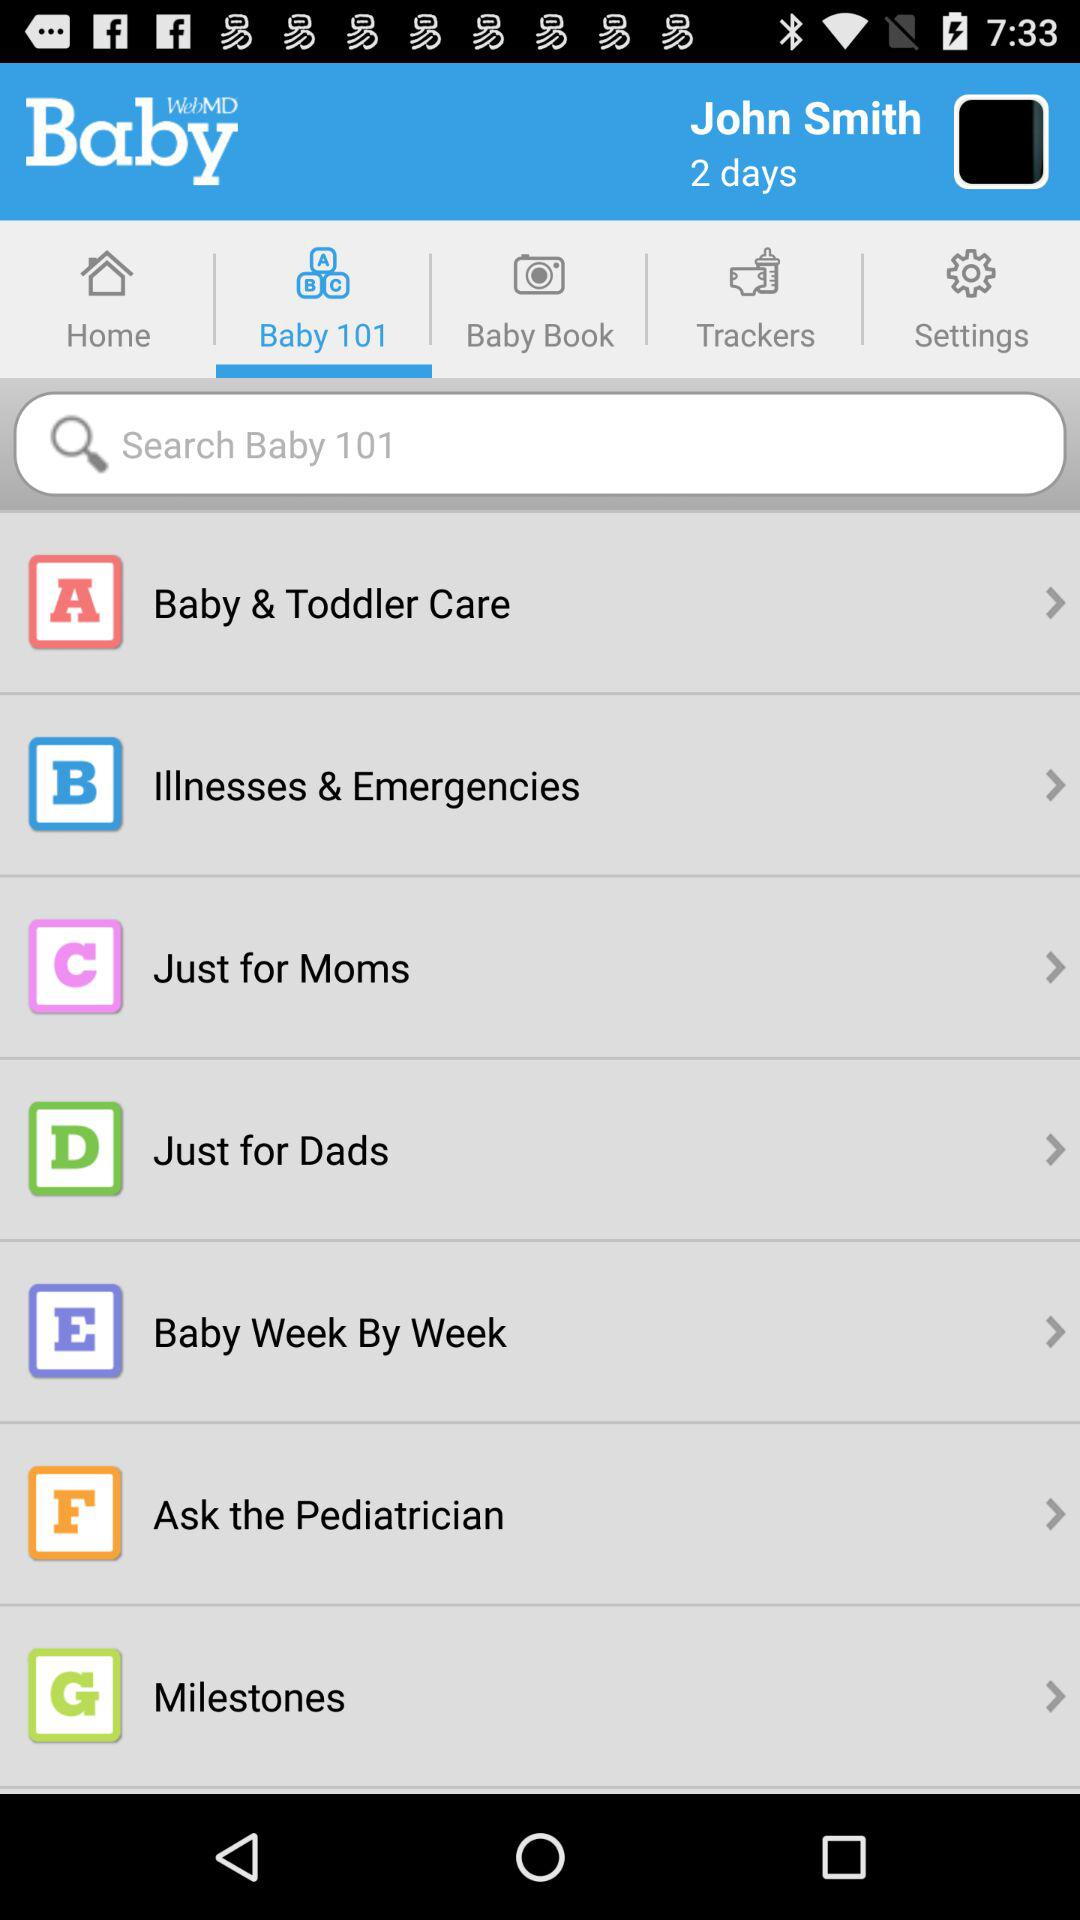What is the name of the application? The application name is WebMD Baby. 